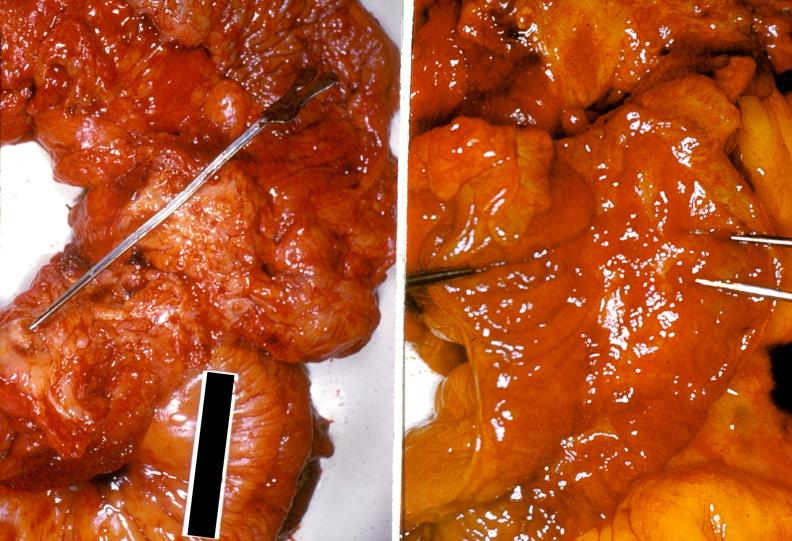why does this image show ileum, ileitis?
Answer the question using a single word or phrase. Due to chronic ulcerative colitis 